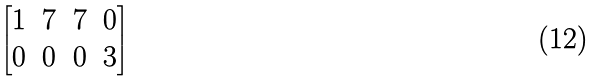<formula> <loc_0><loc_0><loc_500><loc_500>\begin{bmatrix} 1 & 7 & 7 & 0 \\ 0 & 0 & 0 & 3 \end{bmatrix}</formula> 